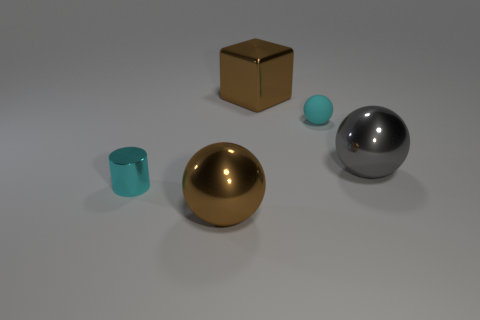Add 3 cyan shiny cylinders. How many objects exist? 8 Subtract all spheres. How many objects are left? 2 Add 1 tiny red metallic objects. How many tiny red metallic objects exist? 1 Subtract 0 gray blocks. How many objects are left? 5 Subtract all yellow things. Subtract all large brown things. How many objects are left? 3 Add 3 brown metal blocks. How many brown metal blocks are left? 4 